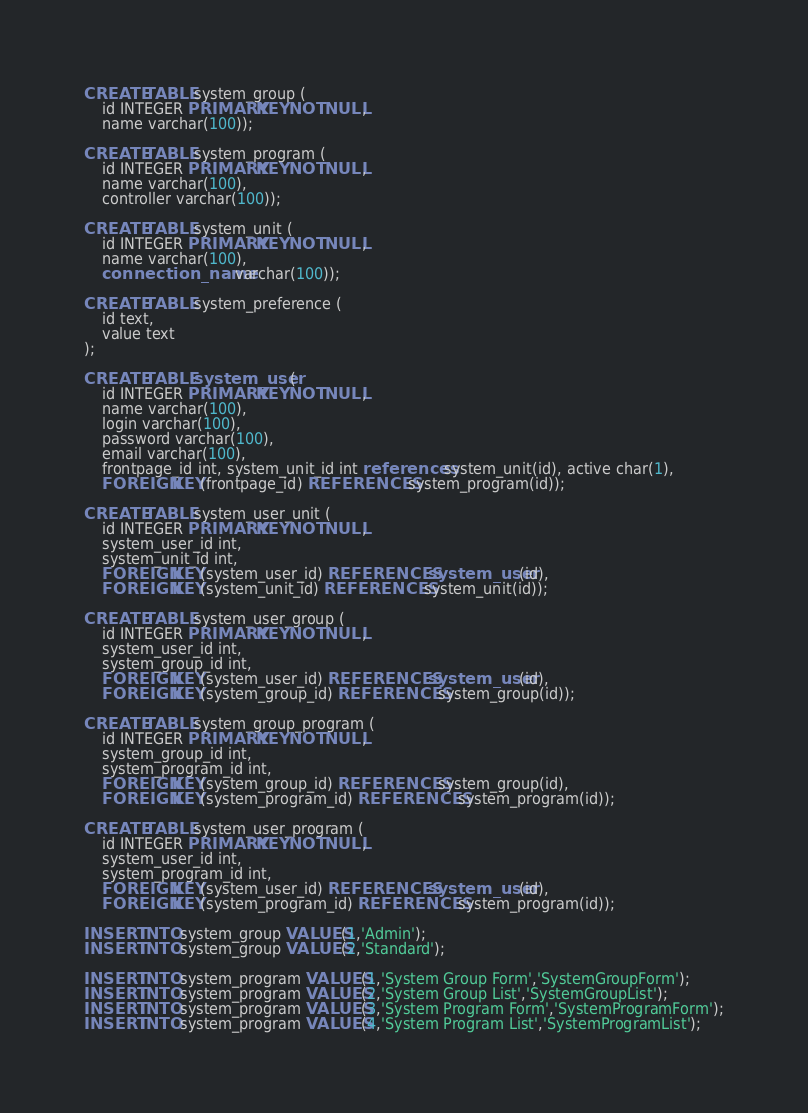Convert code to text. <code><loc_0><loc_0><loc_500><loc_500><_SQL_>CREATE TABLE system_group (
    id INTEGER PRIMARY KEY NOT NULL,
    name varchar(100));

CREATE TABLE system_program (
    id INTEGER PRIMARY KEY NOT NULL,
    name varchar(100),
    controller varchar(100));

CREATE TABLE system_unit (
    id INTEGER PRIMARY KEY NOT NULL,
    name varchar(100),
    connection_name varchar(100));

CREATE TABLE system_preference (
    id text,
    value text
);

CREATE TABLE system_user (
    id INTEGER PRIMARY KEY NOT NULL,
    name varchar(100),
    login varchar(100),
    password varchar(100),
    email varchar(100),
    frontpage_id int, system_unit_id int references system_unit(id), active char(1),
    FOREIGN KEY(frontpage_id) REFERENCES system_program(id));
    
CREATE TABLE system_user_unit (
    id INTEGER PRIMARY KEY NOT NULL,
    system_user_id int,
    system_unit_id int,
    FOREIGN KEY(system_user_id) REFERENCES system_user(id),
    FOREIGN KEY(system_unit_id) REFERENCES system_unit(id));

CREATE TABLE system_user_group (
    id INTEGER PRIMARY KEY NOT NULL,
    system_user_id int,
    system_group_id int,
    FOREIGN KEY(system_user_id) REFERENCES system_user(id),
    FOREIGN KEY(system_group_id) REFERENCES system_group(id));
    
CREATE TABLE system_group_program (
    id INTEGER PRIMARY KEY NOT NULL,
    system_group_id int,
    system_program_id int,
    FOREIGN KEY(system_group_id) REFERENCES system_group(id),
    FOREIGN KEY(system_program_id) REFERENCES system_program(id));
    
CREATE TABLE system_user_program (
    id INTEGER PRIMARY KEY NOT NULL,
    system_user_id int,
    system_program_id int,
    FOREIGN KEY(system_user_id) REFERENCES system_user(id),
    FOREIGN KEY(system_program_id) REFERENCES system_program(id));
        
INSERT INTO system_group VALUES(1,'Admin');
INSERT INTO system_group VALUES(2,'Standard');

INSERT INTO system_program VALUES(1,'System Group Form','SystemGroupForm');
INSERT INTO system_program VALUES(2,'System Group List','SystemGroupList');
INSERT INTO system_program VALUES(3,'System Program Form','SystemProgramForm');
INSERT INTO system_program VALUES(4,'System Program List','SystemProgramList');</code> 